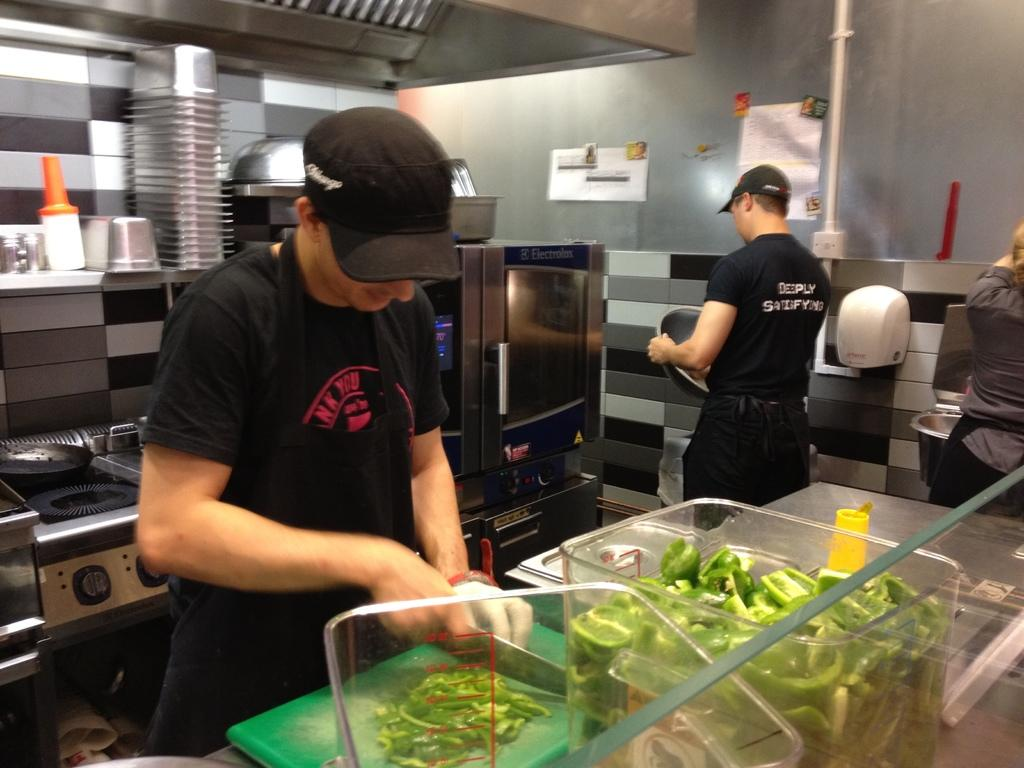<image>
Provide a brief description of the given image. a worker with a shirt that says deeply satisfying 